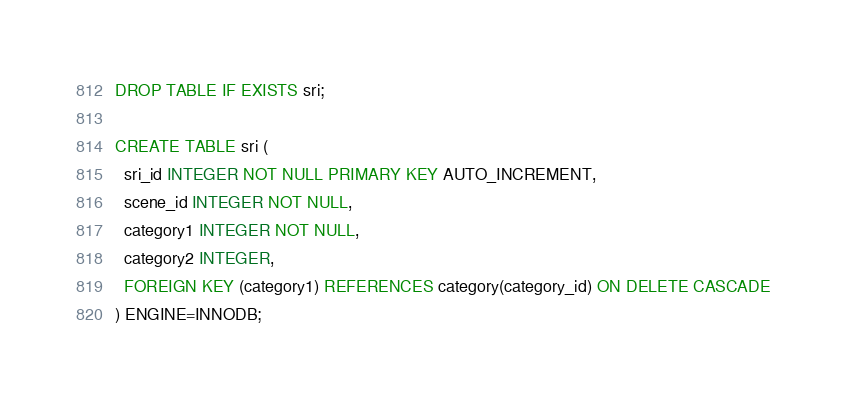Convert code to text. <code><loc_0><loc_0><loc_500><loc_500><_SQL_>DROP TABLE IF EXISTS sri;

CREATE TABLE sri (
  sri_id INTEGER NOT NULL PRIMARY KEY AUTO_INCREMENT,
  scene_id INTEGER NOT NULL,
  category1 INTEGER NOT NULL,
  category2 INTEGER,
  FOREIGN KEY (category1) REFERENCES category(category_id) ON DELETE CASCADE
) ENGINE=INNODB;

</code> 